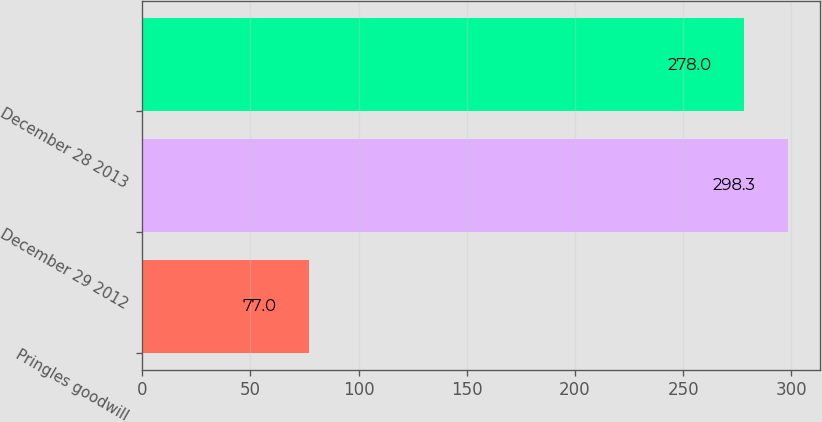Convert chart to OTSL. <chart><loc_0><loc_0><loc_500><loc_500><bar_chart><fcel>Pringles goodwill<fcel>December 29 2012<fcel>December 28 2013<nl><fcel>77<fcel>298.3<fcel>278<nl></chart> 